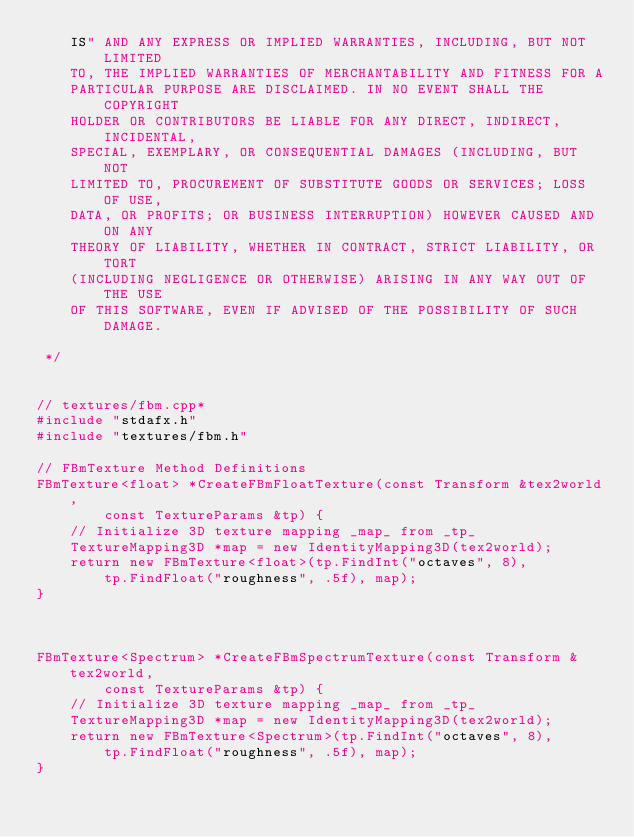Convert code to text. <code><loc_0><loc_0><loc_500><loc_500><_C++_>    IS" AND ANY EXPRESS OR IMPLIED WARRANTIES, INCLUDING, BUT NOT LIMITED
    TO, THE IMPLIED WARRANTIES OF MERCHANTABILITY AND FITNESS FOR A
    PARTICULAR PURPOSE ARE DISCLAIMED. IN NO EVENT SHALL THE COPYRIGHT
    HOLDER OR CONTRIBUTORS BE LIABLE FOR ANY DIRECT, INDIRECT, INCIDENTAL,
    SPECIAL, EXEMPLARY, OR CONSEQUENTIAL DAMAGES (INCLUDING, BUT NOT
    LIMITED TO, PROCUREMENT OF SUBSTITUTE GOODS OR SERVICES; LOSS OF USE,
    DATA, OR PROFITS; OR BUSINESS INTERRUPTION) HOWEVER CAUSED AND ON ANY
    THEORY OF LIABILITY, WHETHER IN CONTRACT, STRICT LIABILITY, OR TORT
    (INCLUDING NEGLIGENCE OR OTHERWISE) ARISING IN ANY WAY OUT OF THE USE
    OF THIS SOFTWARE, EVEN IF ADVISED OF THE POSSIBILITY OF SUCH DAMAGE.

 */


// textures/fbm.cpp*
#include "stdafx.h"
#include "textures/fbm.h"

// FBmTexture Method Definitions
FBmTexture<float> *CreateFBmFloatTexture(const Transform &tex2world,
        const TextureParams &tp) {
    // Initialize 3D texture mapping _map_ from _tp_
    TextureMapping3D *map = new IdentityMapping3D(tex2world);
    return new FBmTexture<float>(tp.FindInt("octaves", 8),
        tp.FindFloat("roughness", .5f), map);
}



FBmTexture<Spectrum> *CreateFBmSpectrumTexture(const Transform &tex2world,
        const TextureParams &tp) {
    // Initialize 3D texture mapping _map_ from _tp_
    TextureMapping3D *map = new IdentityMapping3D(tex2world);
    return new FBmTexture<Spectrum>(tp.FindInt("octaves", 8),
        tp.FindFloat("roughness", .5f), map);
}


</code> 